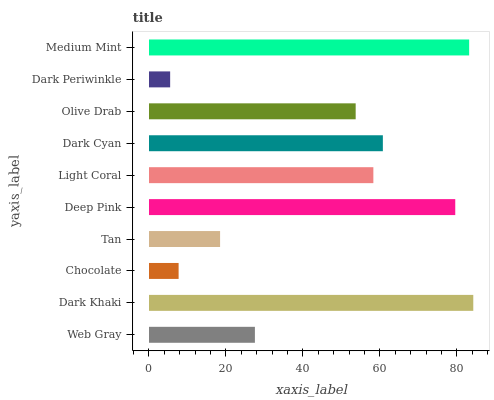Is Dark Periwinkle the minimum?
Answer yes or no. Yes. Is Dark Khaki the maximum?
Answer yes or no. Yes. Is Chocolate the minimum?
Answer yes or no. No. Is Chocolate the maximum?
Answer yes or no. No. Is Dark Khaki greater than Chocolate?
Answer yes or no. Yes. Is Chocolate less than Dark Khaki?
Answer yes or no. Yes. Is Chocolate greater than Dark Khaki?
Answer yes or no. No. Is Dark Khaki less than Chocolate?
Answer yes or no. No. Is Light Coral the high median?
Answer yes or no. Yes. Is Olive Drab the low median?
Answer yes or no. Yes. Is Dark Cyan the high median?
Answer yes or no. No. Is Dark Periwinkle the low median?
Answer yes or no. No. 